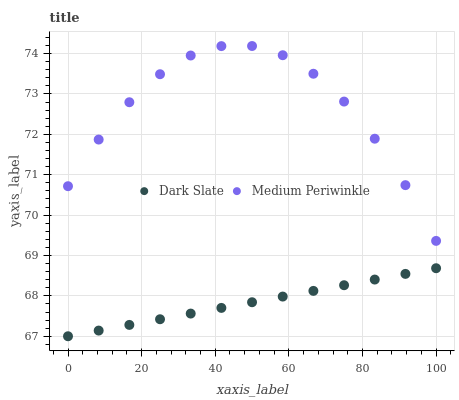Does Dark Slate have the minimum area under the curve?
Answer yes or no. Yes. Does Medium Periwinkle have the maximum area under the curve?
Answer yes or no. Yes. Does Medium Periwinkle have the minimum area under the curve?
Answer yes or no. No. Is Dark Slate the smoothest?
Answer yes or no. Yes. Is Medium Periwinkle the roughest?
Answer yes or no. Yes. Is Medium Periwinkle the smoothest?
Answer yes or no. No. Does Dark Slate have the lowest value?
Answer yes or no. Yes. Does Medium Periwinkle have the lowest value?
Answer yes or no. No. Does Medium Periwinkle have the highest value?
Answer yes or no. Yes. Is Dark Slate less than Medium Periwinkle?
Answer yes or no. Yes. Is Medium Periwinkle greater than Dark Slate?
Answer yes or no. Yes. Does Dark Slate intersect Medium Periwinkle?
Answer yes or no. No. 